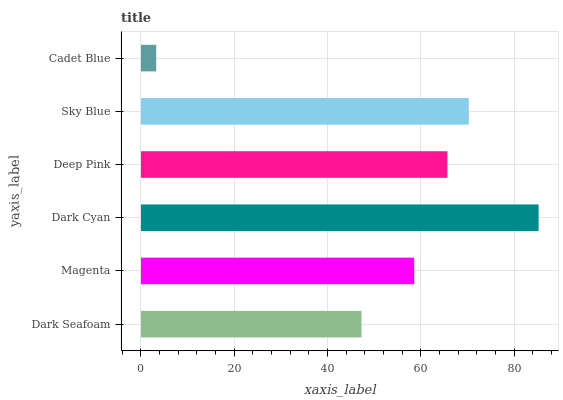Is Cadet Blue the minimum?
Answer yes or no. Yes. Is Dark Cyan the maximum?
Answer yes or no. Yes. Is Magenta the minimum?
Answer yes or no. No. Is Magenta the maximum?
Answer yes or no. No. Is Magenta greater than Dark Seafoam?
Answer yes or no. Yes. Is Dark Seafoam less than Magenta?
Answer yes or no. Yes. Is Dark Seafoam greater than Magenta?
Answer yes or no. No. Is Magenta less than Dark Seafoam?
Answer yes or no. No. Is Deep Pink the high median?
Answer yes or no. Yes. Is Magenta the low median?
Answer yes or no. Yes. Is Cadet Blue the high median?
Answer yes or no. No. Is Cadet Blue the low median?
Answer yes or no. No. 